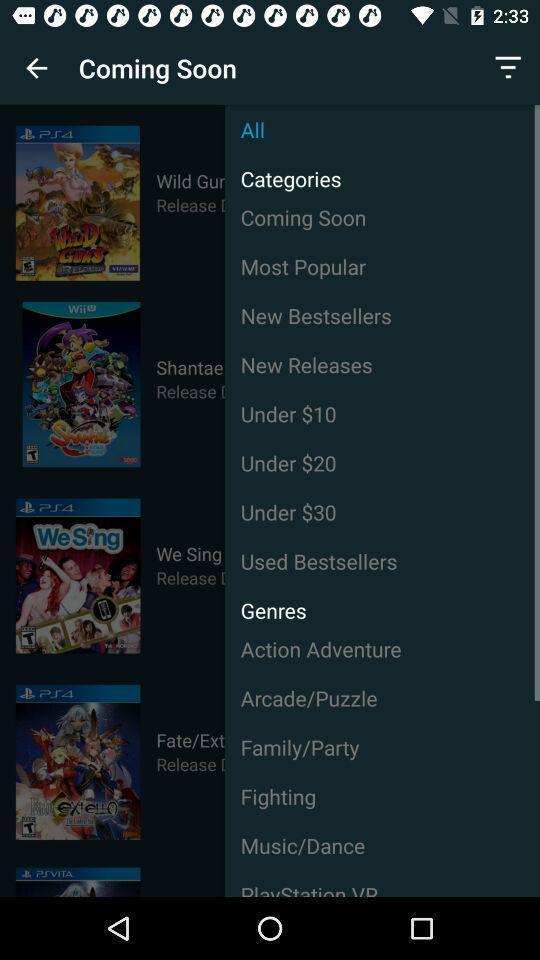Give me a summary of this screen capture. Window displaying a movie app. 